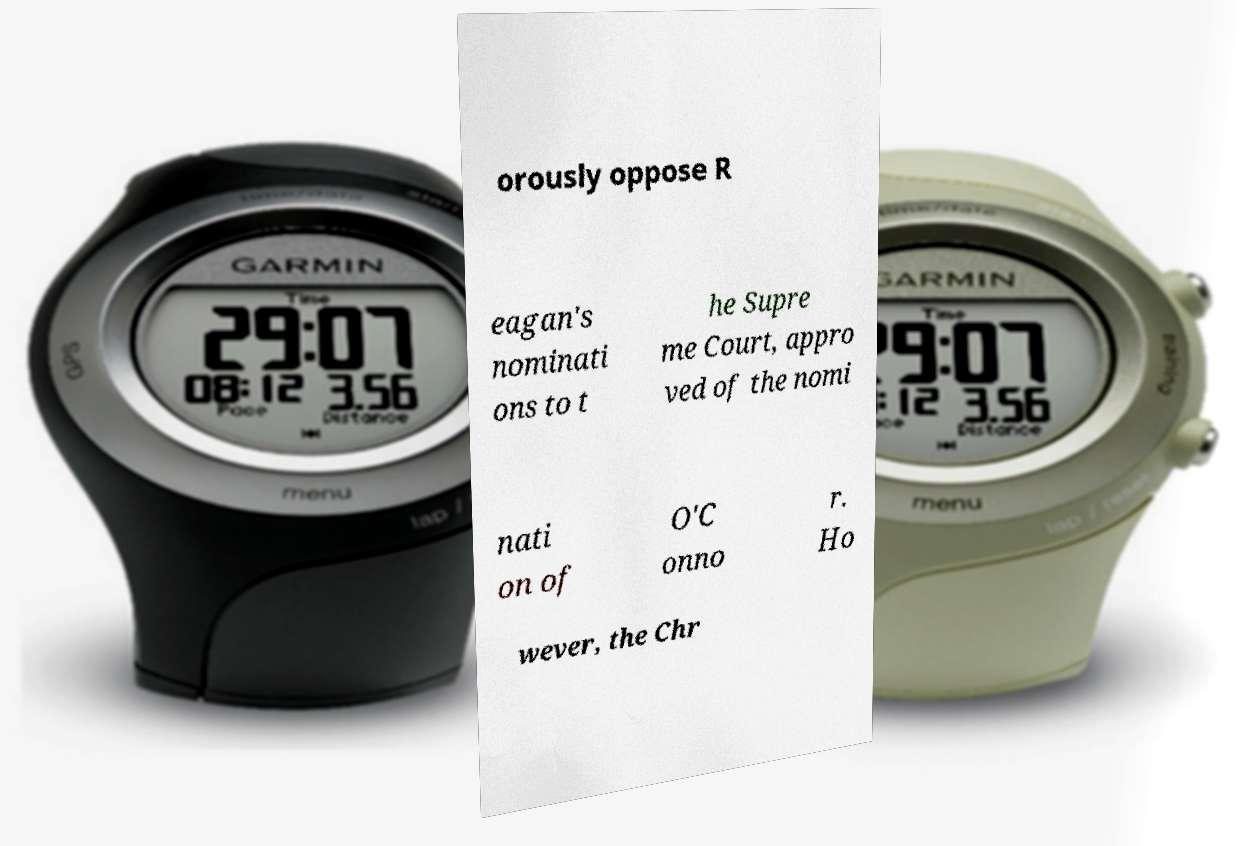There's text embedded in this image that I need extracted. Can you transcribe it verbatim? orously oppose R eagan's nominati ons to t he Supre me Court, appro ved of the nomi nati on of O'C onno r. Ho wever, the Chr 